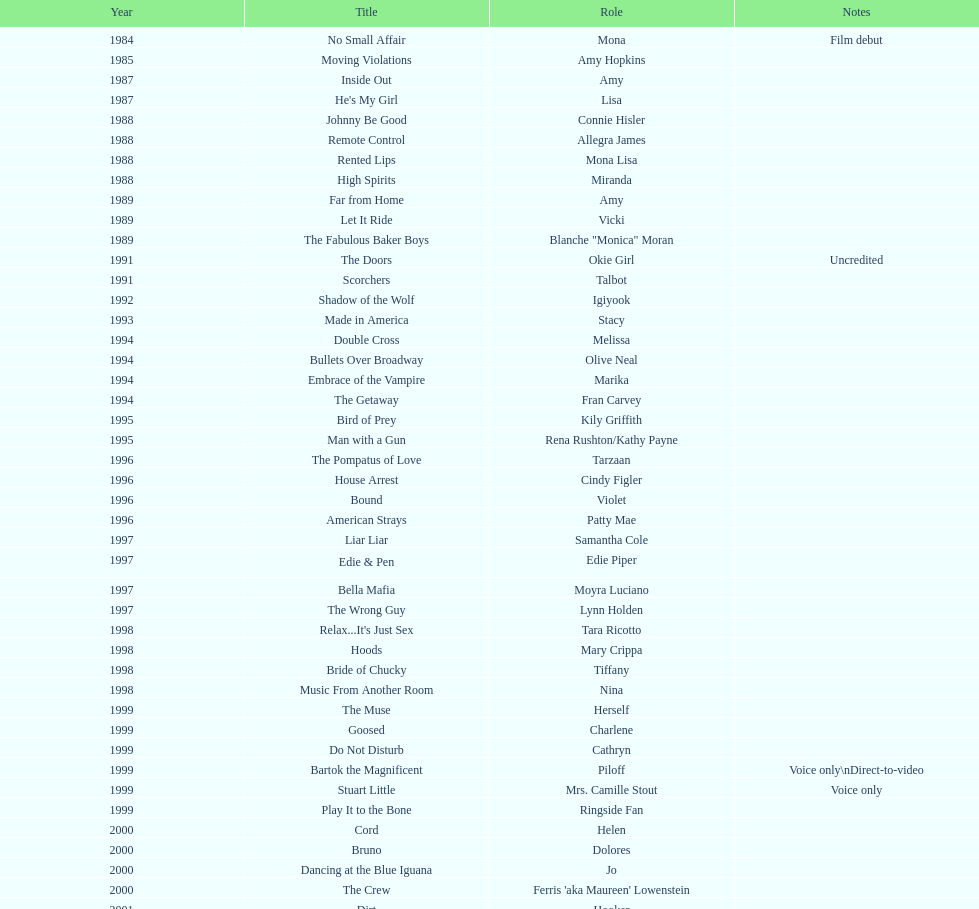In what number of films is jennifer tilly performing a voice-over part? 5. 